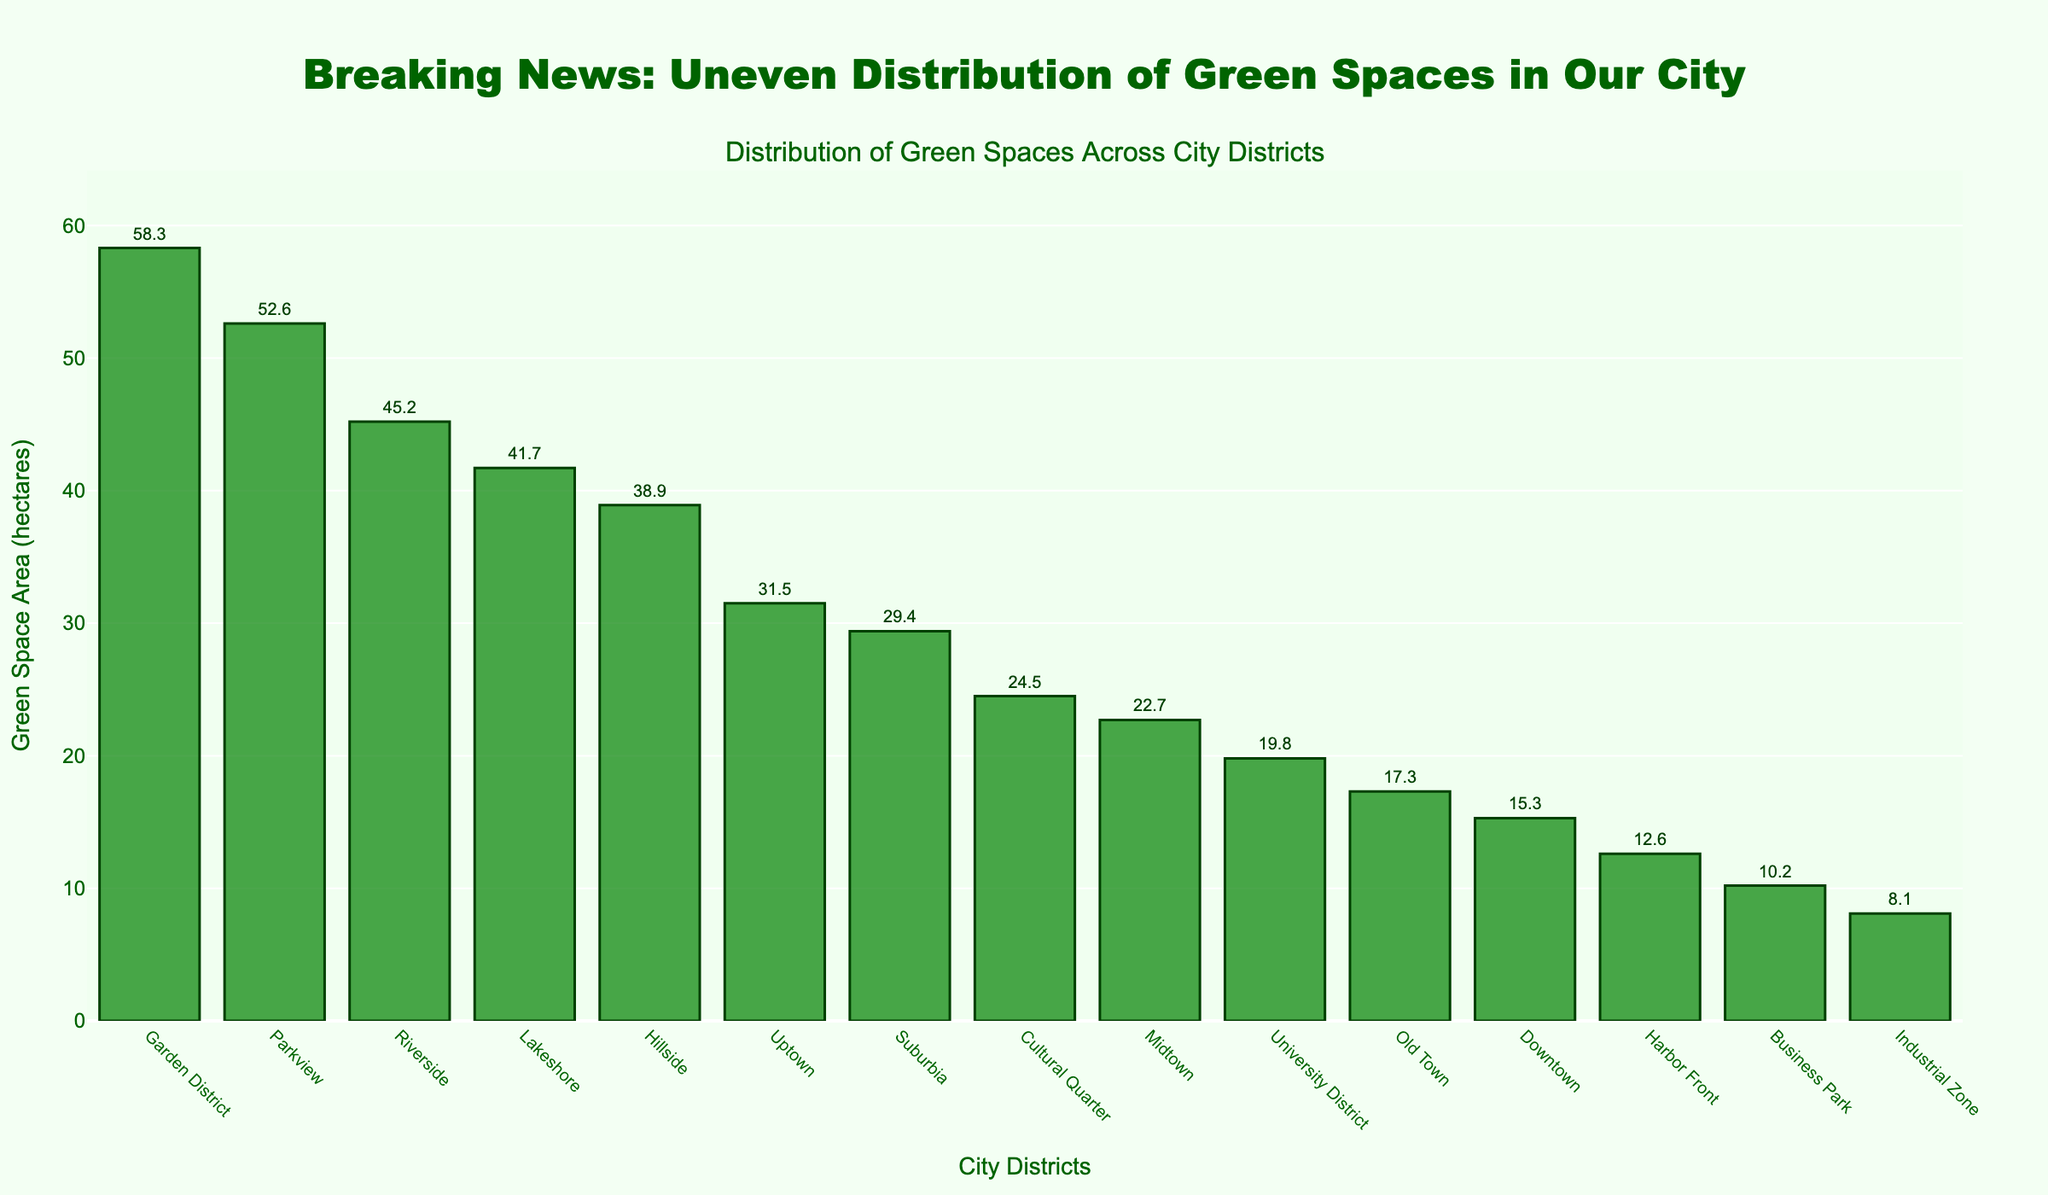What are the top three districts with the most green space? First, identify and refer to the heights of the top three bars in the bar chart. These heights correspond to the areas of green space. Then, read the district names associated with these bars.
Answer: Garden District, Parkview, Riverside Which district has the least green space and how much is it? Look for the shortest bar in the bar chart, which represents the district with the smallest green space area. Then, read the district name and the green space area corresponding to that bar.
Answer: Industrial Zone, 8.1 hectares Is Midtown's green space area greater than or less than Lakeshore's? Refer to the heights of the bars for Midtown and Lakeshore. Compare their green space areas to determine which one is greater.
Answer: Less than Which districts have a green space area between 20 and 30 hectares? Identify the bars where the height falls within the 20 to 30 hectares range. Read the district names corresponding to these bars.
Answer: Midtown, University District, Suburbia, Cultural Quarter How many districts have a green space area greater than 35 hectares? Count the bars in the bar chart whose heights are above the 35 hectares mark.
Answer: 7 districts What are the district names and green space areas of the bottom three districts in terms of green space? Identify the three shortest bars in the bar chart and note their associated district names and green space areas. These represent the bottom three districts in terms of green space.
Answer: Industrial Zone, Harbor Front, Business Park; 8.1, 12.6, 10.2 hectares 